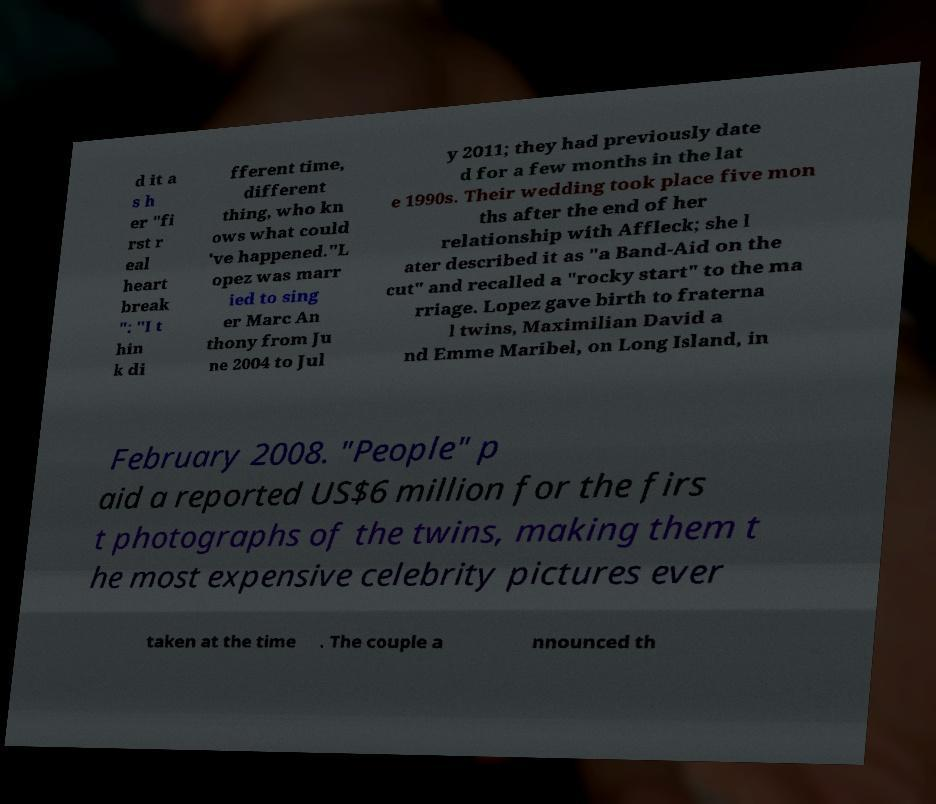Please read and relay the text visible in this image. What does it say? d it a s h er "fi rst r eal heart break ": "I t hin k di fferent time, different thing, who kn ows what could 've happened."L opez was marr ied to sing er Marc An thony from Ju ne 2004 to Jul y 2011; they had previously date d for a few months in the lat e 1990s. Their wedding took place five mon ths after the end of her relationship with Affleck; she l ater described it as "a Band-Aid on the cut" and recalled a "rocky start" to the ma rriage. Lopez gave birth to fraterna l twins, Maximilian David a nd Emme Maribel, on Long Island, in February 2008. "People" p aid a reported US$6 million for the firs t photographs of the twins, making them t he most expensive celebrity pictures ever taken at the time . The couple a nnounced th 